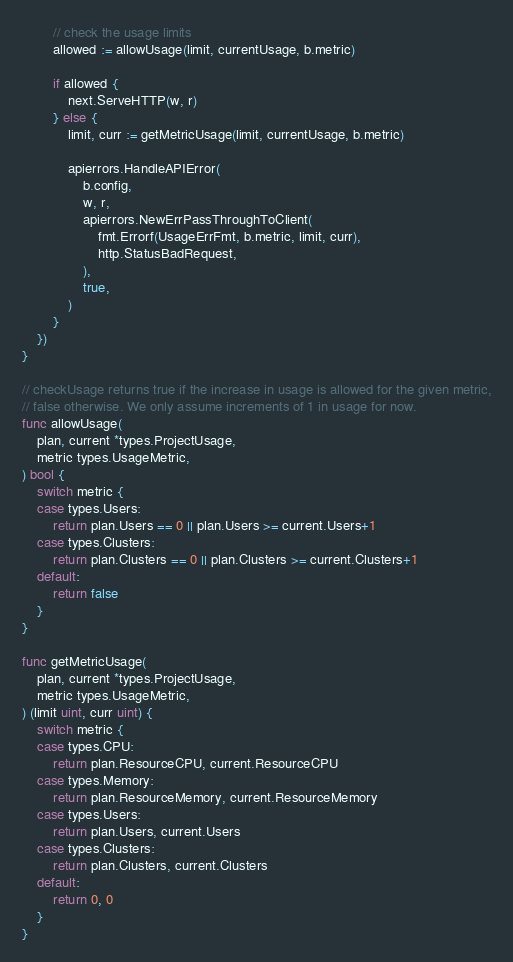Convert code to text. <code><loc_0><loc_0><loc_500><loc_500><_Go_>
		// check the usage limits
		allowed := allowUsage(limit, currentUsage, b.metric)

		if allowed {
			next.ServeHTTP(w, r)
		} else {
			limit, curr := getMetricUsage(limit, currentUsage, b.metric)

			apierrors.HandleAPIError(
				b.config,
				w, r,
				apierrors.NewErrPassThroughToClient(
					fmt.Errorf(UsageErrFmt, b.metric, limit, curr),
					http.StatusBadRequest,
				),
				true,
			)
		}
	})
}

// checkUsage returns true if the increase in usage is allowed for the given metric,
// false otherwise. We only assume increments of 1 in usage for now.
func allowUsage(
	plan, current *types.ProjectUsage,
	metric types.UsageMetric,
) bool {
	switch metric {
	case types.Users:
		return plan.Users == 0 || plan.Users >= current.Users+1
	case types.Clusters:
		return plan.Clusters == 0 || plan.Clusters >= current.Clusters+1
	default:
		return false
	}
}

func getMetricUsage(
	plan, current *types.ProjectUsage,
	metric types.UsageMetric,
) (limit uint, curr uint) {
	switch metric {
	case types.CPU:
		return plan.ResourceCPU, current.ResourceCPU
	case types.Memory:
		return plan.ResourceMemory, current.ResourceMemory
	case types.Users:
		return plan.Users, current.Users
	case types.Clusters:
		return plan.Clusters, current.Clusters
	default:
		return 0, 0
	}
}
</code> 